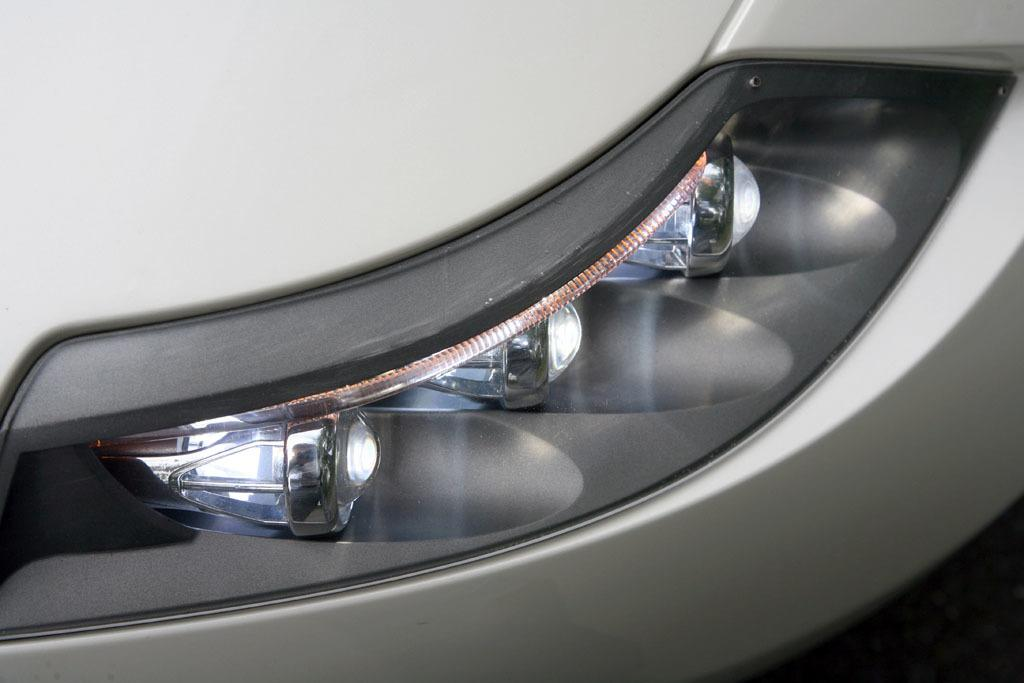What is the main subject of the image? There is a vehicle in the image. What color is the vehicle? The vehicle is grey in color. What can be said about the headlights of the vehicle? The headlights of the vehicle are black and white in color. What type of iron is being used to style the hair of the police officer in the image? There is no iron, hair, or police officer present in the image; it only features a grey vehicle with black and white headlights. 